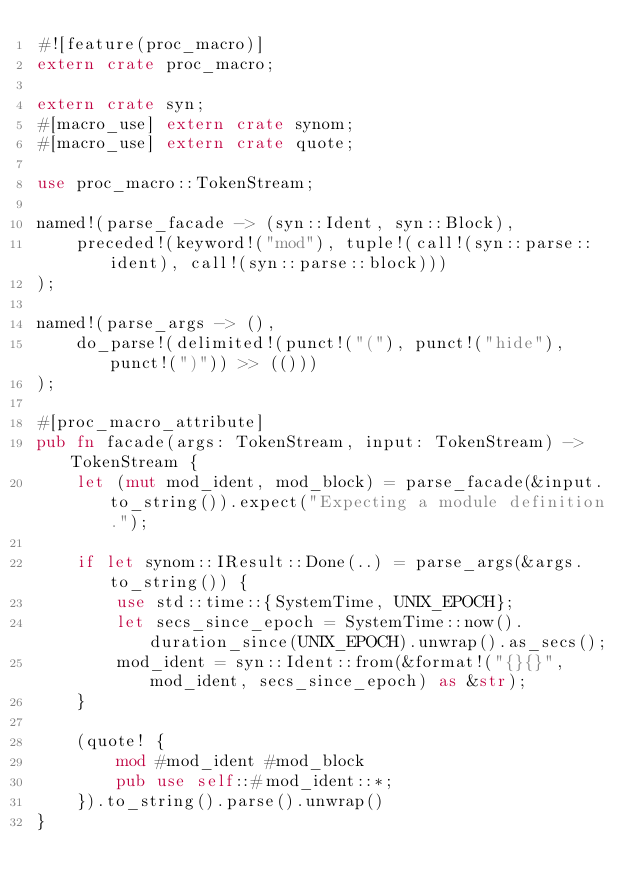<code> <loc_0><loc_0><loc_500><loc_500><_Rust_>#![feature(proc_macro)]
extern crate proc_macro;

extern crate syn;
#[macro_use] extern crate synom;
#[macro_use] extern crate quote;

use proc_macro::TokenStream;

named!(parse_facade -> (syn::Ident, syn::Block),
    preceded!(keyword!("mod"), tuple!(call!(syn::parse::ident), call!(syn::parse::block)))
);

named!(parse_args -> (),
    do_parse!(delimited!(punct!("("), punct!("hide"), punct!(")")) >> (()))
);

#[proc_macro_attribute]
pub fn facade(args: TokenStream, input: TokenStream) -> TokenStream {
    let (mut mod_ident, mod_block) = parse_facade(&input.to_string()).expect("Expecting a module definition.");

    if let synom::IResult::Done(..) = parse_args(&args.to_string()) {
        use std::time::{SystemTime, UNIX_EPOCH};
        let secs_since_epoch = SystemTime::now().duration_since(UNIX_EPOCH).unwrap().as_secs();
        mod_ident = syn::Ident::from(&format!("{}{}", mod_ident, secs_since_epoch) as &str);
    }

    (quote! {
        mod #mod_ident #mod_block
        pub use self::#mod_ident::*;
    }).to_string().parse().unwrap()
}
</code> 